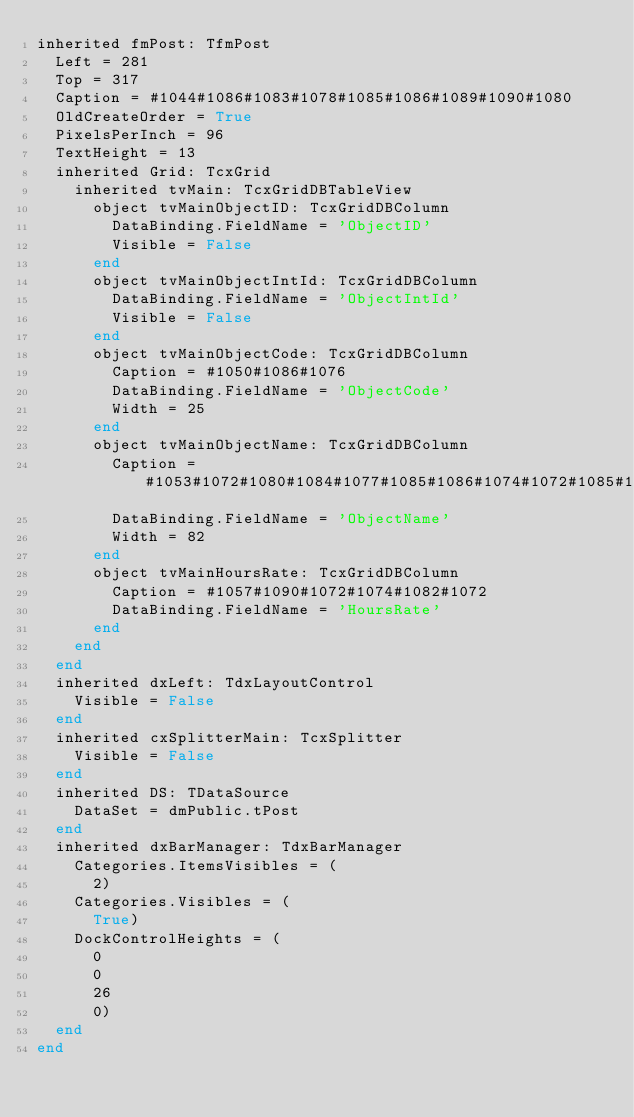Convert code to text. <code><loc_0><loc_0><loc_500><loc_500><_Pascal_>inherited fmPost: TfmPost
  Left = 281
  Top = 317
  Caption = #1044#1086#1083#1078#1085#1086#1089#1090#1080
  OldCreateOrder = True
  PixelsPerInch = 96
  TextHeight = 13
  inherited Grid: TcxGrid
    inherited tvMain: TcxGridDBTableView
      object tvMainObjectID: TcxGridDBColumn
        DataBinding.FieldName = 'ObjectID'
        Visible = False
      end
      object tvMainObjectIntId: TcxGridDBColumn
        DataBinding.FieldName = 'ObjectIntId'
        Visible = False
      end
      object tvMainObjectCode: TcxGridDBColumn
        Caption = #1050#1086#1076
        DataBinding.FieldName = 'ObjectCode'
        Width = 25
      end
      object tvMainObjectName: TcxGridDBColumn
        Caption = #1053#1072#1080#1084#1077#1085#1086#1074#1072#1085#1080#1077
        DataBinding.FieldName = 'ObjectName'
        Width = 82
      end
      object tvMainHoursRate: TcxGridDBColumn
        Caption = #1057#1090#1072#1074#1082#1072
        DataBinding.FieldName = 'HoursRate'
      end
    end
  end
  inherited dxLeft: TdxLayoutControl
    Visible = False
  end
  inherited cxSplitterMain: TcxSplitter
    Visible = False
  end
  inherited DS: TDataSource
    DataSet = dmPublic.tPost
  end
  inherited dxBarManager: TdxBarManager
    Categories.ItemsVisibles = (
      2)
    Categories.Visibles = (
      True)
    DockControlHeights = (
      0
      0
      26
      0)
  end
end
</code> 